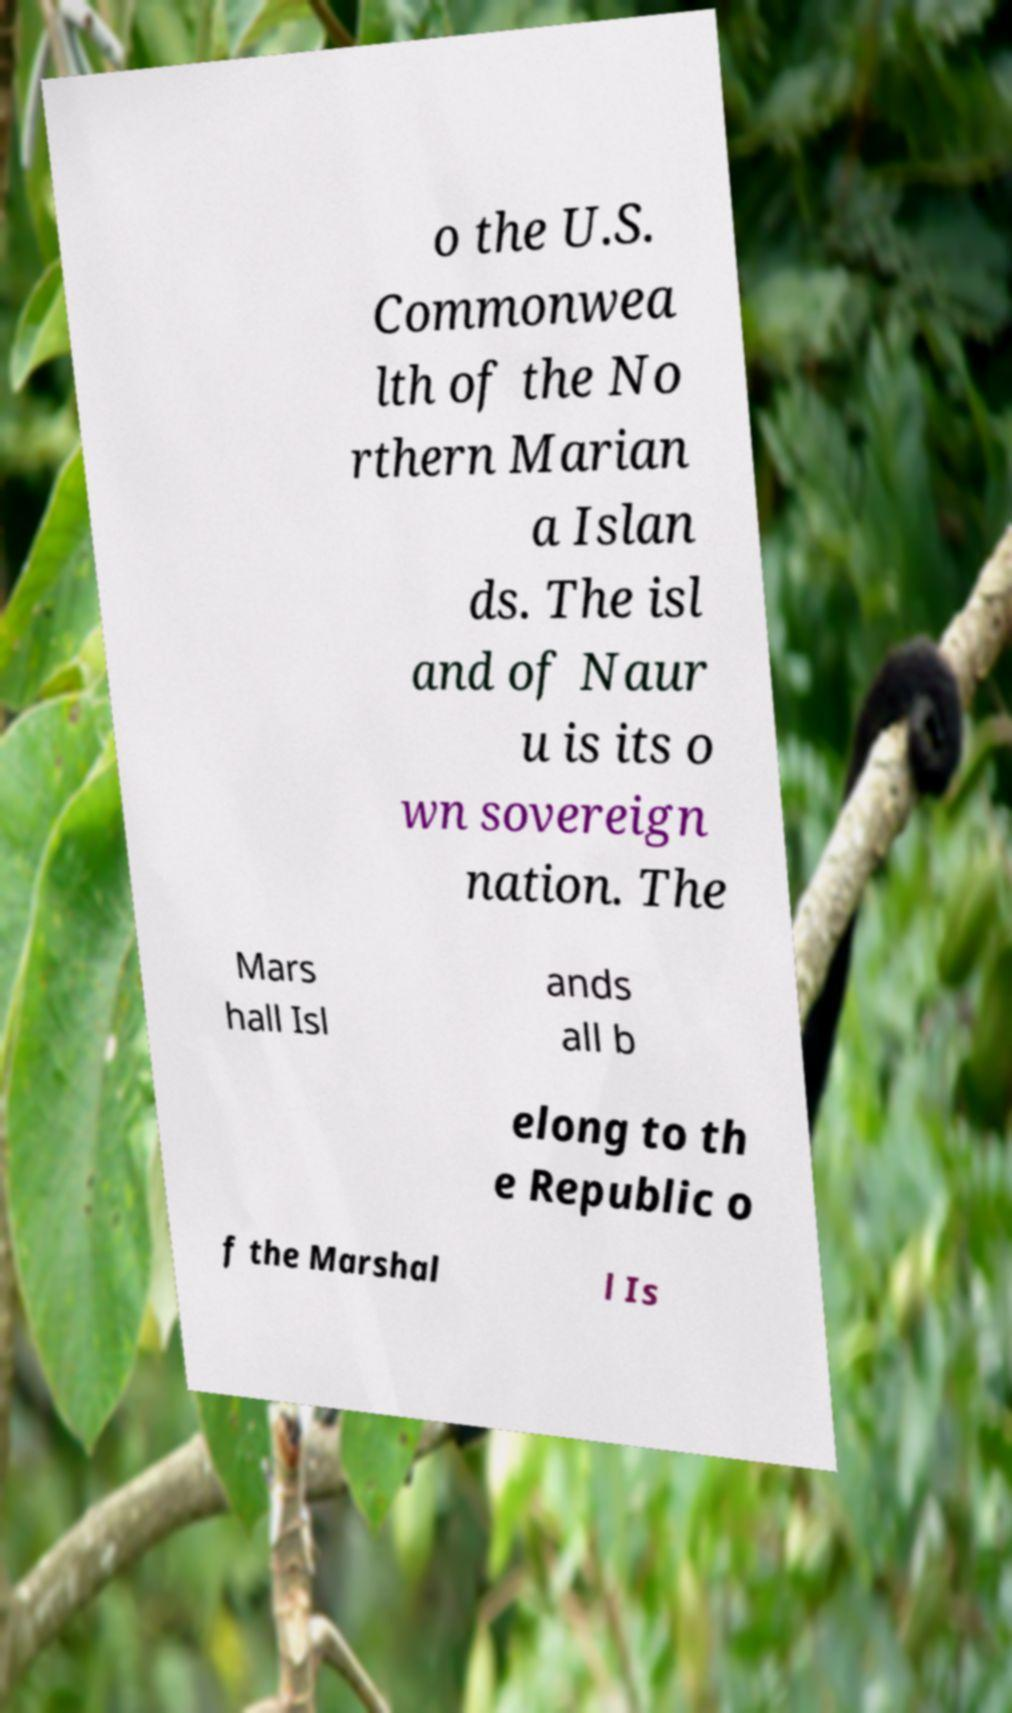For documentation purposes, I need the text within this image transcribed. Could you provide that? o the U.S. Commonwea lth of the No rthern Marian a Islan ds. The isl and of Naur u is its o wn sovereign nation. The Mars hall Isl ands all b elong to th e Republic o f the Marshal l Is 